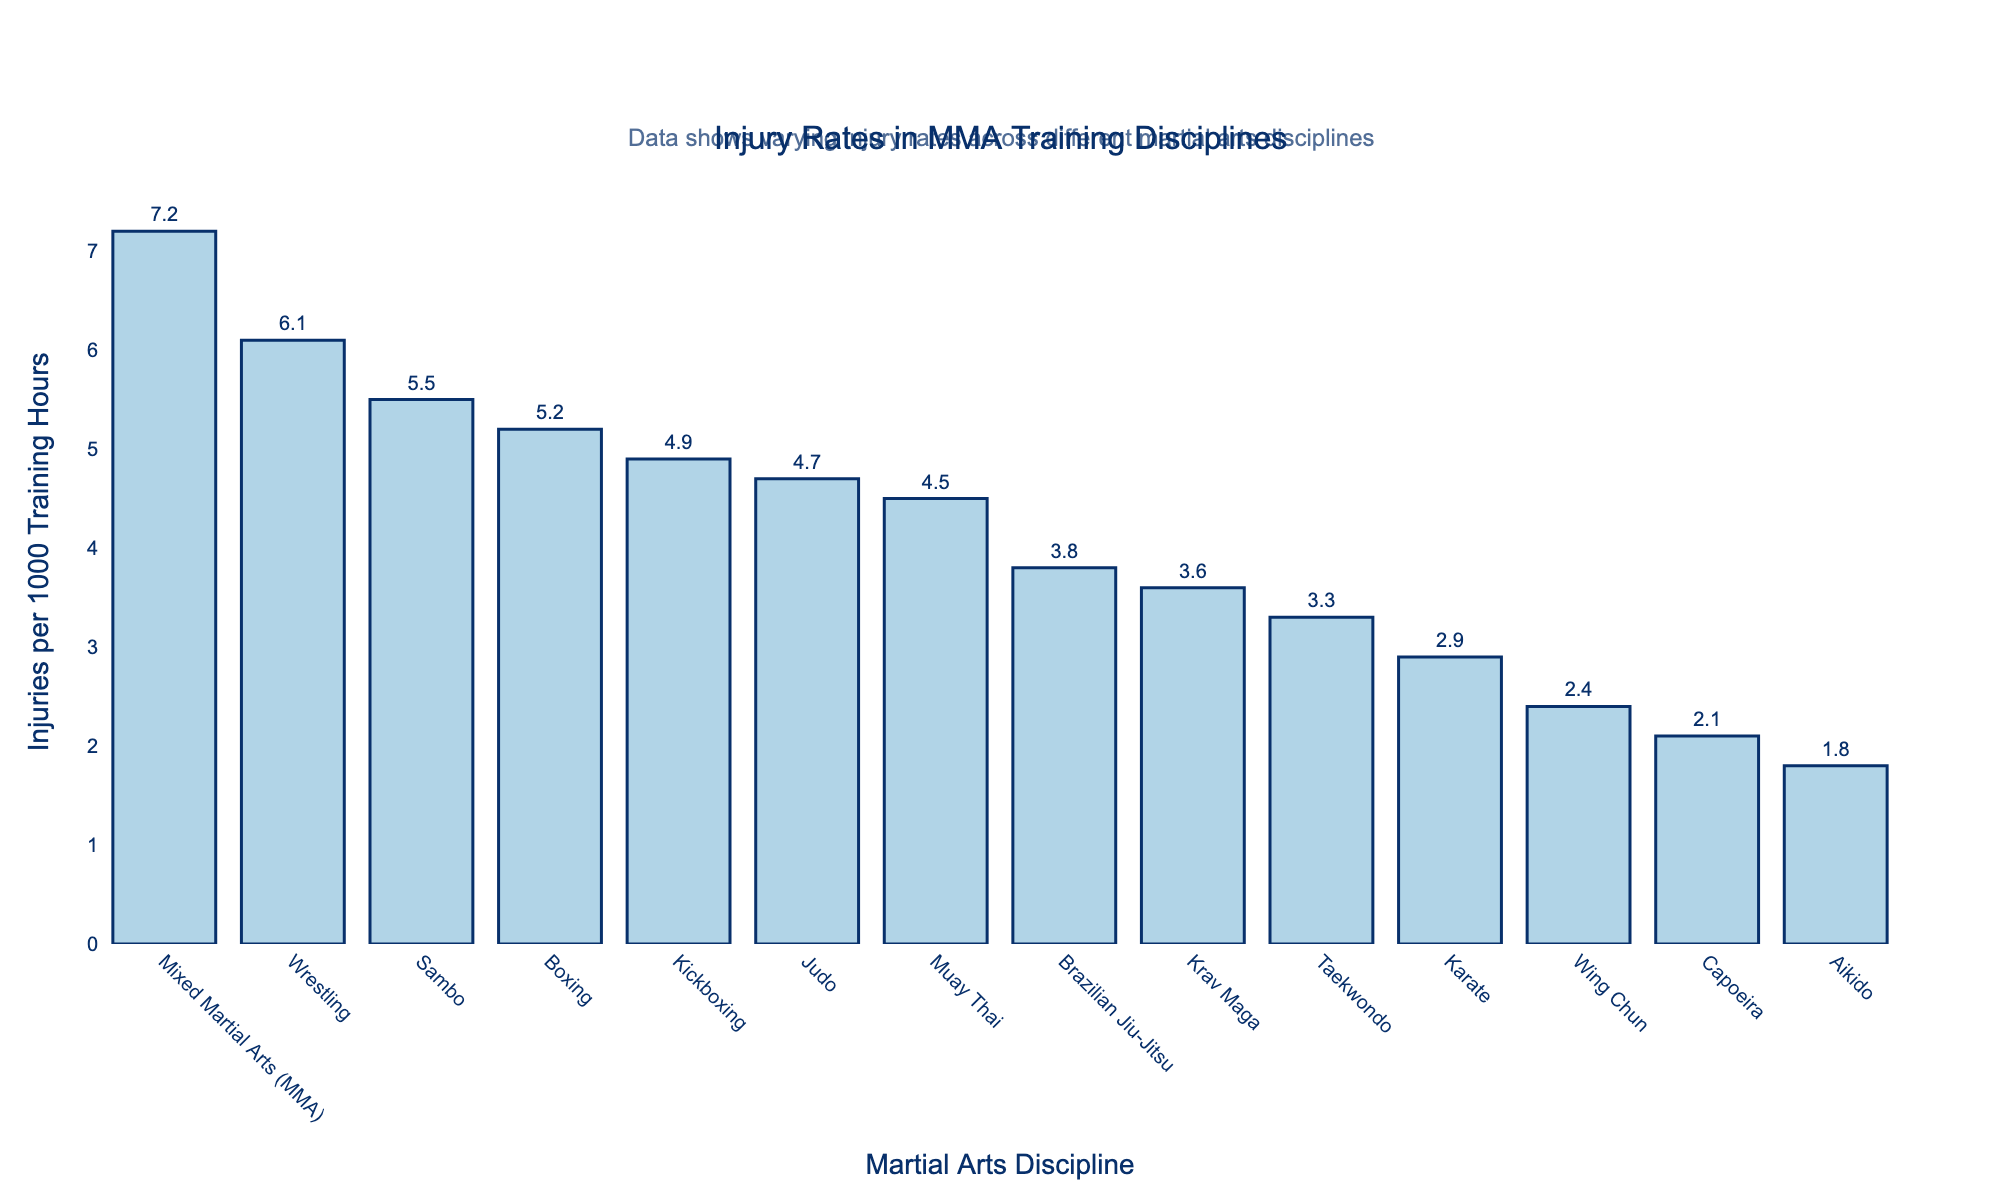What's the average injury rate across all disciplines? Add up each injury rate (5.2 + 3.8 + 4.5 + 6.1 + 2.9 + 4.7 + 3.3 + 5.5 + 4.9 + 7.2 + 3.6 + 2.1 + 2.4 + 1.8 = 58) and divide by the number of disciplines (58 / 14).
Answer: 4.14 Which discipline has the highest injury rate? The tallest bar represents Mixed Martial Arts (MMA) with an injury rate of 7.2 per 1000 training hours.
Answer: Mixed Martial Arts (MMA) Which two disciplines have the closest injury rates? Compare the heights of the bars; Boxing (5.2), and Sambo (5.5) have close rates, with a difference of 0.3.
Answer: Boxing and Sambo What is the difference in injury rates between Wrestling and Boxing? Find the bars for Wrestling (6.1) and Boxing (5.2), then subtract Boxing from Wrestling (6.1 - 5.2).
Answer: 0.9 What percentage increase in injury rate does MMA have compared to Karate? Locate MMA (7.2) and Karate (2.9); calculate the difference (7.2 - 2.9 = 4.3), then divide by Karate's rate (4.3 / 2.9) and multiply by 100.
Answer: 148.3% Which disciplines have injury rates less than 3 per 1000 training hours? Identify bars shorter than the 3 mark: Karate (2.9), Capoeira (2.1), Wing Chun (2.4), and Aikido (1.8).
Answer: Karate, Capoeira, Wing Chun, and Aikido What's the sum of the injury rates for Brazilian Jiu-Jitsu, Muay Thai, and Kickboxing? Add the rates: Brazilian Jiu-Jitsu (3.8) + Muay Thai (4.5) + Kickboxing (4.9) = 13.2.
Answer: 13.2 Which discipline has a smaller injury rate, Judo or Taekwondo? Compare the bars: Judo (4.7) and Taekwondo (3.3) and note that Taekwondo is smaller.
Answer: Taekwondo How many disciplines have an injury rate above 5 per 1000 training hours? Count the bars higher than the 5 mark: Boxing, Wrestling, Sambo, Kickboxing, MMA.
Answer: 5 